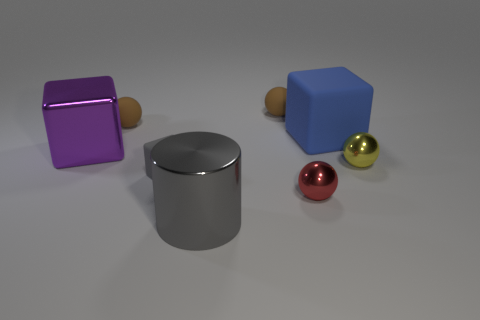Subtract all gray cubes. How many cubes are left? 2 Add 1 large cubes. How many objects exist? 9 Subtract all red spheres. How many spheres are left? 3 Subtract all blocks. How many objects are left? 5 Subtract all gray cubes. Subtract all red cylinders. How many cubes are left? 2 Subtract all green blocks. How many green balls are left? 0 Subtract all small blue matte cubes. Subtract all small gray matte objects. How many objects are left? 7 Add 4 small red spheres. How many small red spheres are left? 5 Add 2 large gray metallic spheres. How many large gray metallic spheres exist? 2 Subtract 0 red blocks. How many objects are left? 8 